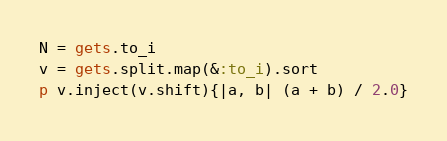<code> <loc_0><loc_0><loc_500><loc_500><_Ruby_>N = gets.to_i
v = gets.split.map(&:to_i).sort
p v.inject(v.shift){|a, b| (a + b) / 2.0}
</code> 